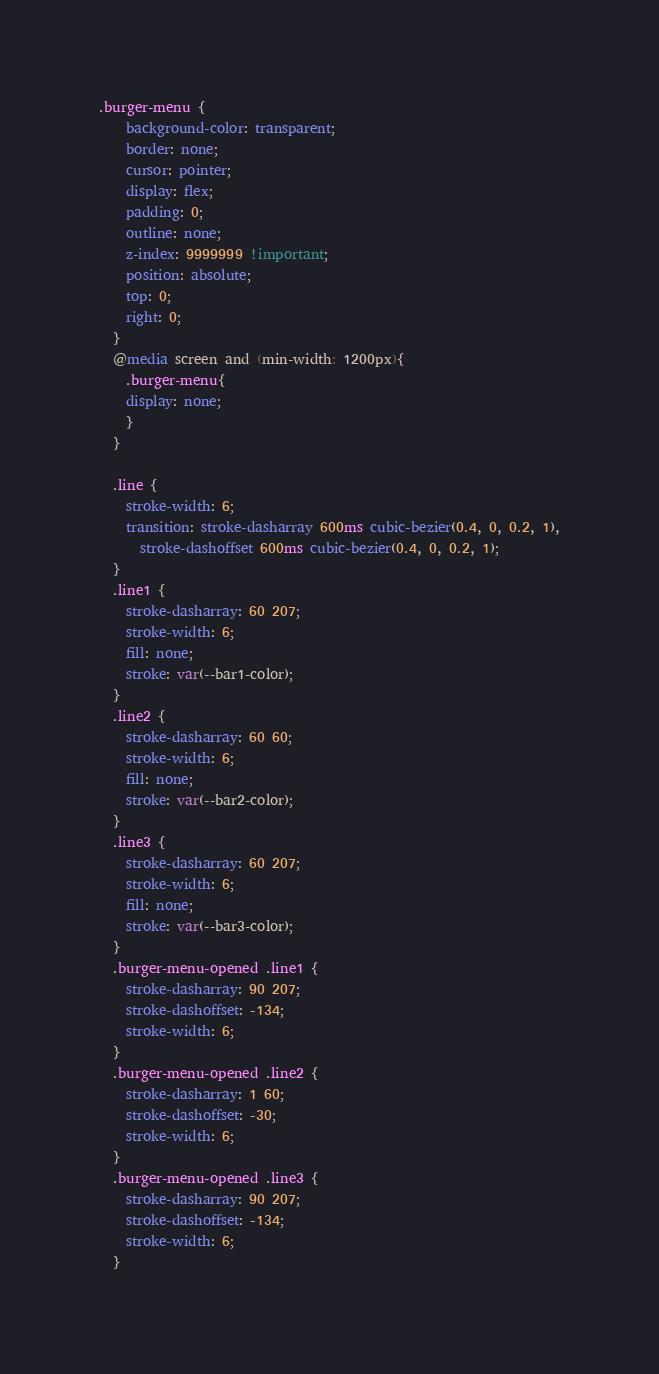Convert code to text. <code><loc_0><loc_0><loc_500><loc_500><_CSS_>.burger-menu {
    background-color: transparent;
    border: none;
    cursor: pointer;
    display: flex;
    padding: 0;
    outline: none;
    z-index: 9999999 !important;
    position: absolute;
    top: 0;
    right: 0;
  }
  @media screen and (min-width: 1200px){
    .burger-menu{
    display: none;
    }
  }

  .line {
    stroke-width: 6;
    transition: stroke-dasharray 600ms cubic-bezier(0.4, 0, 0.2, 1),
      stroke-dashoffset 600ms cubic-bezier(0.4, 0, 0.2, 1);
  }
  .line1 {
    stroke-dasharray: 60 207;
    stroke-width: 6;
    fill: none;
    stroke: var(--bar1-color);
  }
  .line2 {
    stroke-dasharray: 60 60;
    stroke-width: 6;
    fill: none;
    stroke: var(--bar2-color);
  }
  .line3 {
    stroke-dasharray: 60 207;
    stroke-width: 6;
    fill: none;
    stroke: var(--bar3-color);
  }
  .burger-menu-opened .line1 {
    stroke-dasharray: 90 207;
    stroke-dashoffset: -134;
    stroke-width: 6;
  }
  .burger-menu-opened .line2 {
    stroke-dasharray: 1 60;
    stroke-dashoffset: -30;
    stroke-width: 6;
  }
  .burger-menu-opened .line3 {
    stroke-dasharray: 90 207;
    stroke-dashoffset: -134;
    stroke-width: 6;
  }</code> 